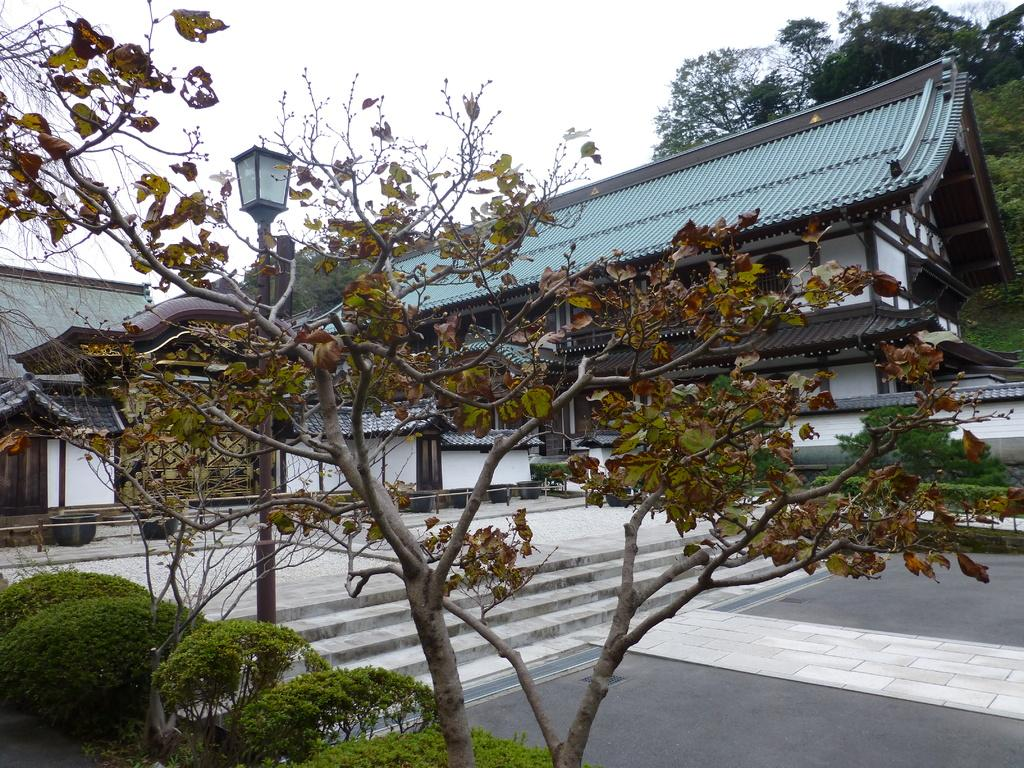What type of vegetation can be seen in the image? There are trees in the image. What structure is visible in the background of the image? There is a house in the background of the image. What else can be seen in the background of the image besides the house? Trees and the sky are visible in the background of the image. What feature is present in front of the house? There is a path in front of the house. Can you tell me how many eggs the man is holding in the image? There is no man or eggs present in the image. What type of offer is being made by the trees in the image? There is no offer being made by the trees in the image; they are simply trees. 